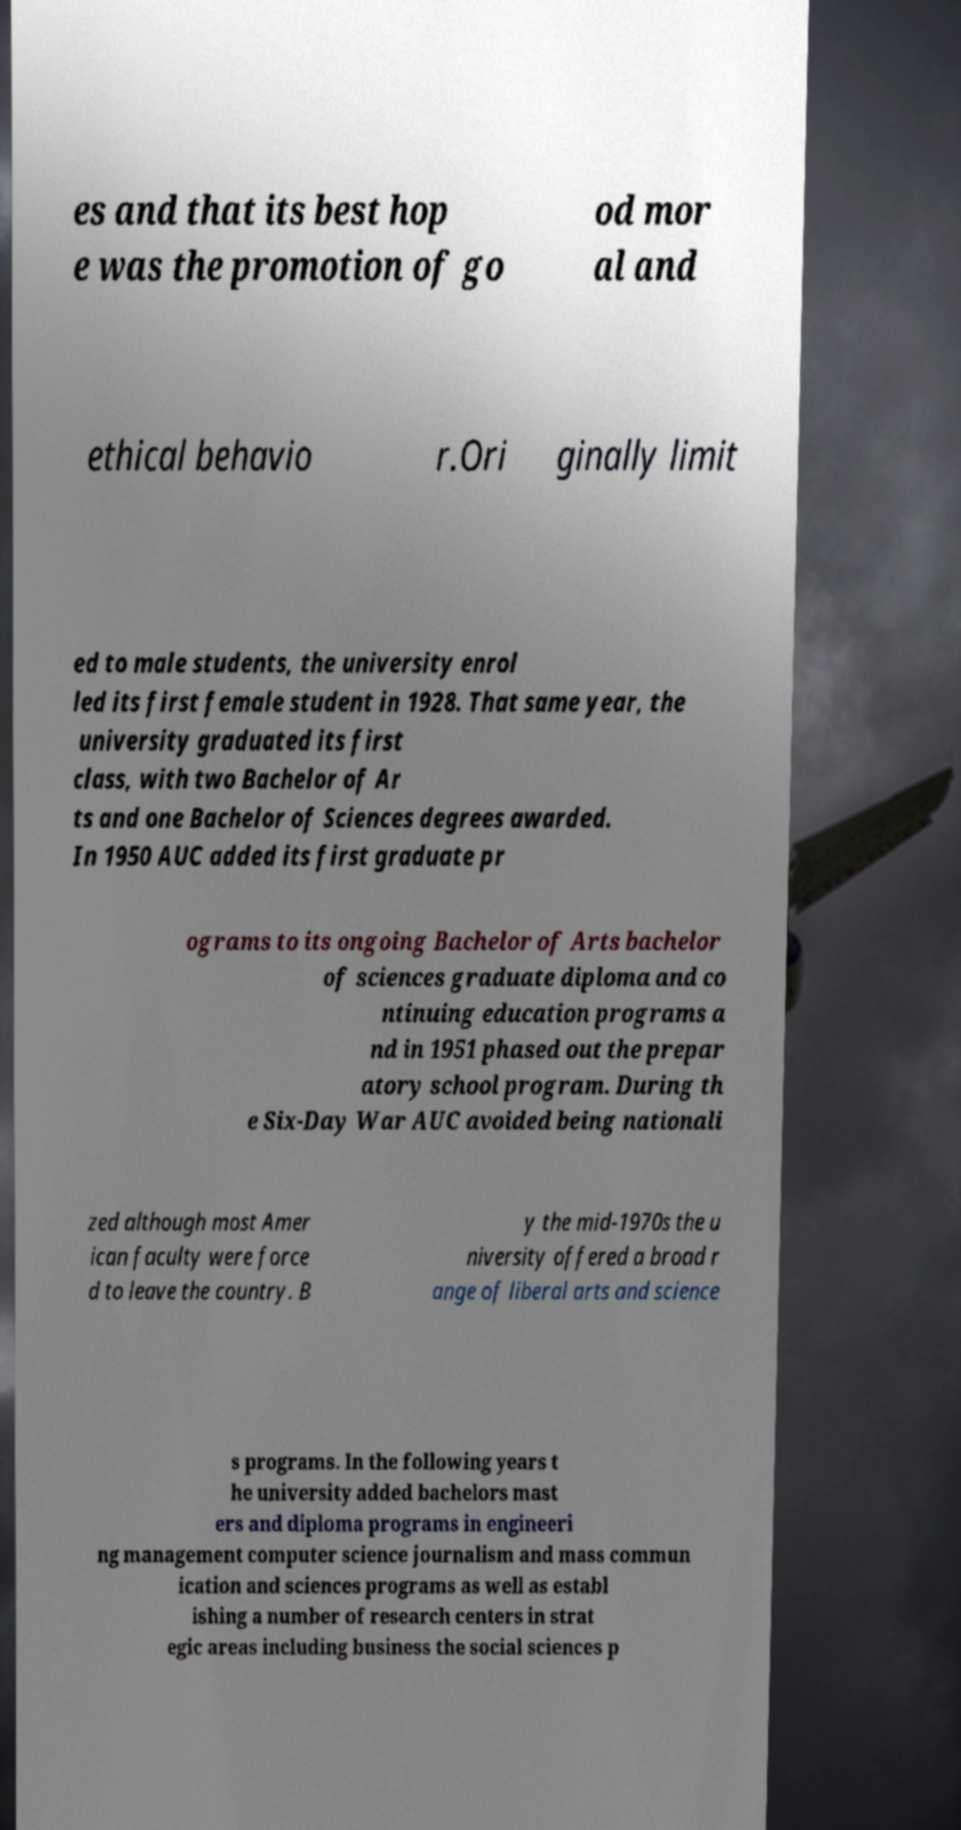Please read and relay the text visible in this image. What does it say? es and that its best hop e was the promotion of go od mor al and ethical behavio r.Ori ginally limit ed to male students, the university enrol led its first female student in 1928. That same year, the university graduated its first class, with two Bachelor of Ar ts and one Bachelor of Sciences degrees awarded. In 1950 AUC added its first graduate pr ograms to its ongoing Bachelor of Arts bachelor of sciences graduate diploma and co ntinuing education programs a nd in 1951 phased out the prepar atory school program. During th e Six-Day War AUC avoided being nationali zed although most Amer ican faculty were force d to leave the country. B y the mid-1970s the u niversity offered a broad r ange of liberal arts and science s programs. In the following years t he university added bachelors mast ers and diploma programs in engineeri ng management computer science journalism and mass commun ication and sciences programs as well as establ ishing a number of research centers in strat egic areas including business the social sciences p 